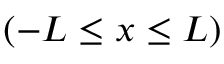<formula> <loc_0><loc_0><loc_500><loc_500>( - L \leq x \leq L )</formula> 